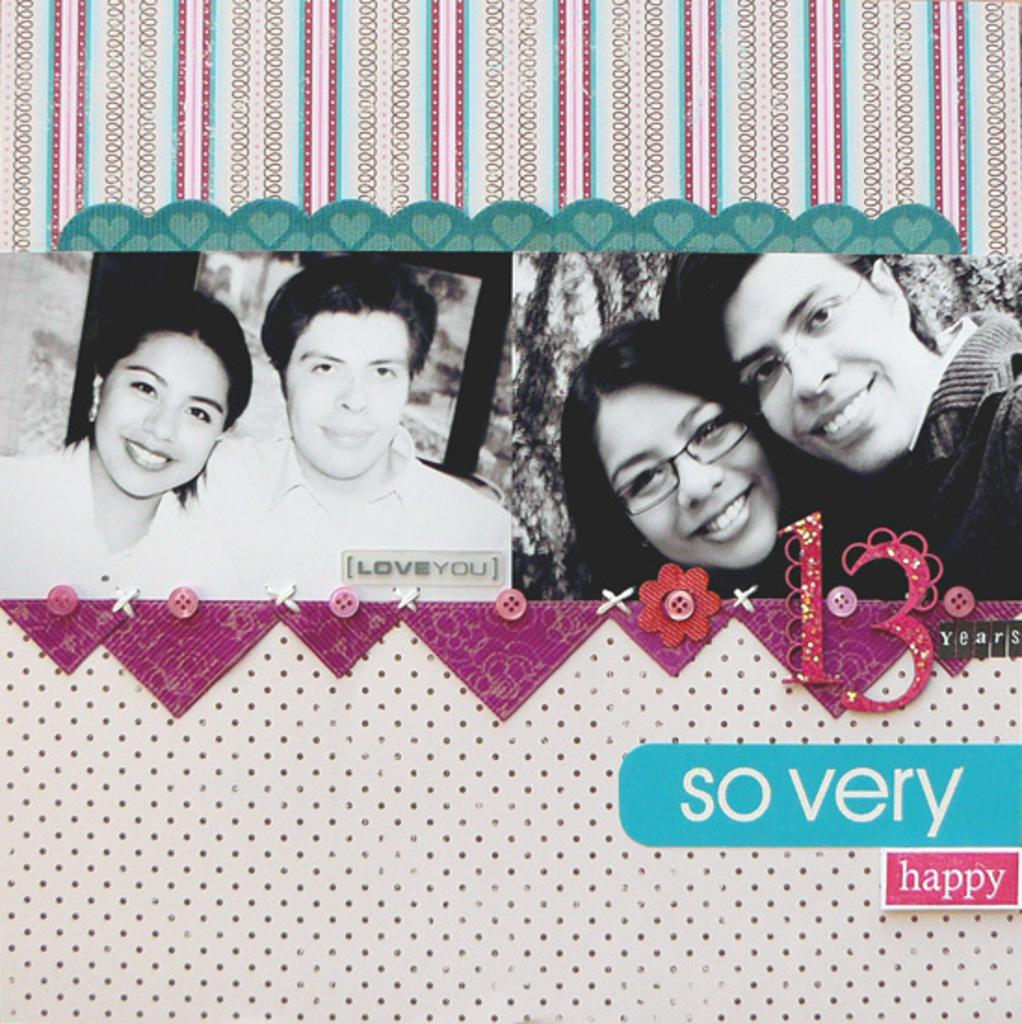What object is the main focus of the image? There is a greeting card in the image. What is depicted on the greeting card? The greeting card has a picture of a couple. Are there any words or phrases on the greeting card? Yes, there is text on the greeting card. Where is the faucet located in the image? There is no faucet present in the image; it only features a greeting card with a picture of a couple and text. 